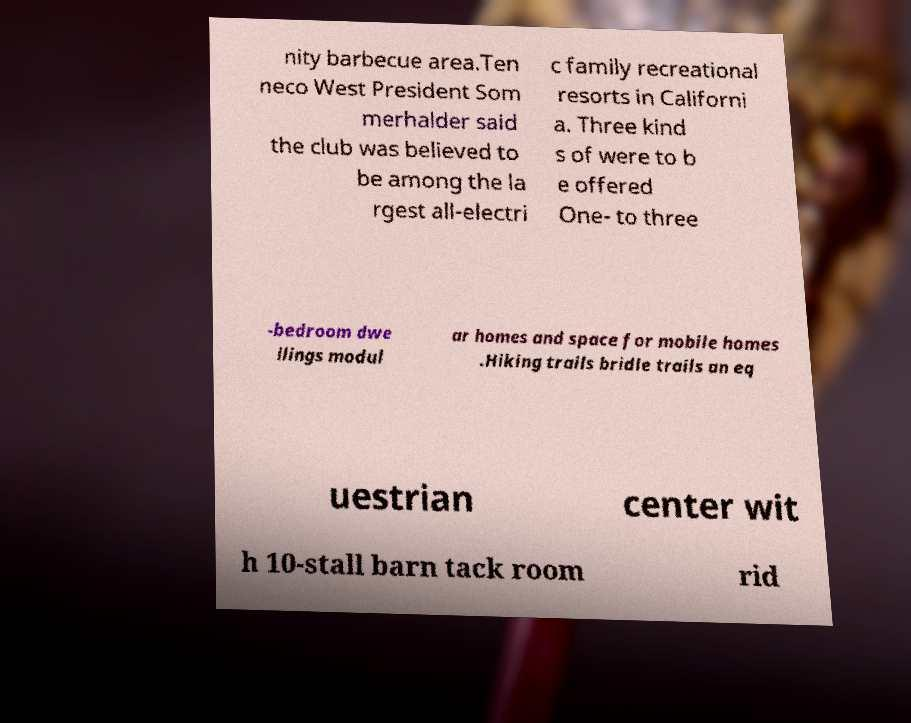For documentation purposes, I need the text within this image transcribed. Could you provide that? nity barbecue area.Ten neco West President Som merhalder said the club was believed to be among the la rgest all-electri c family recreational resorts in Californi a. Three kind s of were to b e offered One- to three -bedroom dwe llings modul ar homes and space for mobile homes .Hiking trails bridle trails an eq uestrian center wit h 10-stall barn tack room rid 